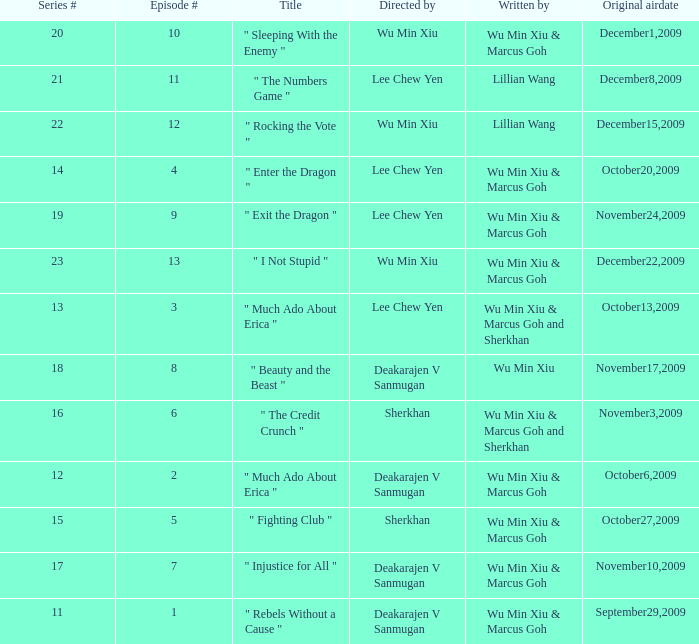What was the title for episode 2? " Much Ado About Erica ". 